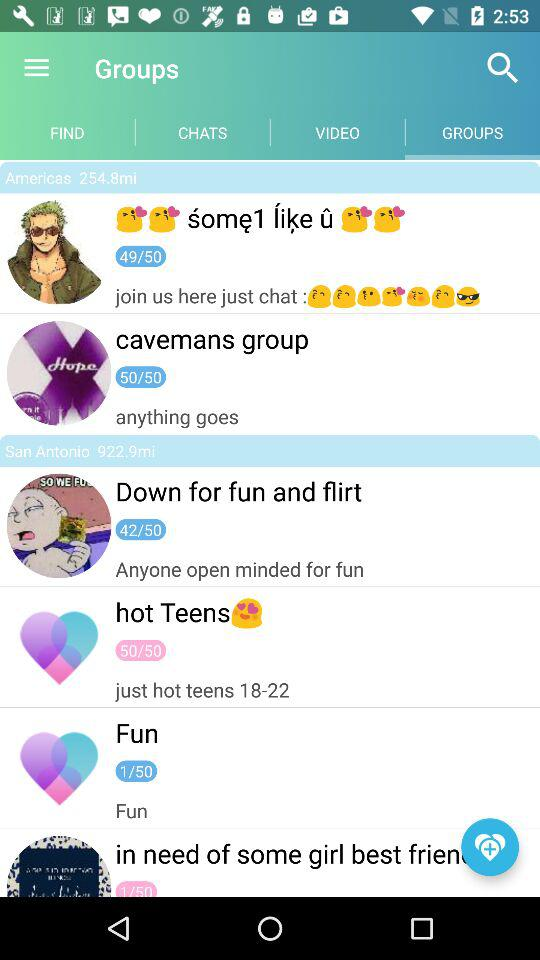How many groups have 50/50 members?
Answer the question using a single word or phrase. 2 